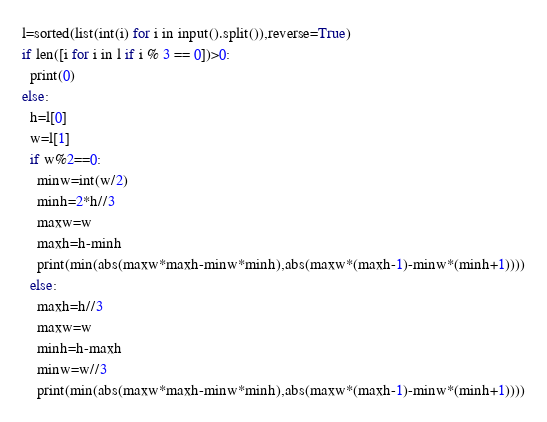Convert code to text. <code><loc_0><loc_0><loc_500><loc_500><_Python_>l=sorted(list(int(i) for i in input().split()),reverse=True)
if len([i for i in l if i % 3 == 0])>0:
  print(0)
else:
  h=l[0]
  w=l[1]
  if w%2==0:
    minw=int(w/2)
    minh=2*h//3
    maxw=w
    maxh=h-minh
    print(min(abs(maxw*maxh-minw*minh),abs(maxw*(maxh-1)-minw*(minh+1))))
  else:
    maxh=h//3
    maxw=w
    minh=h-maxh
    minw=w//3
    print(min(abs(maxw*maxh-minw*minh),abs(maxw*(maxh-1)-minw*(minh+1))))
</code> 